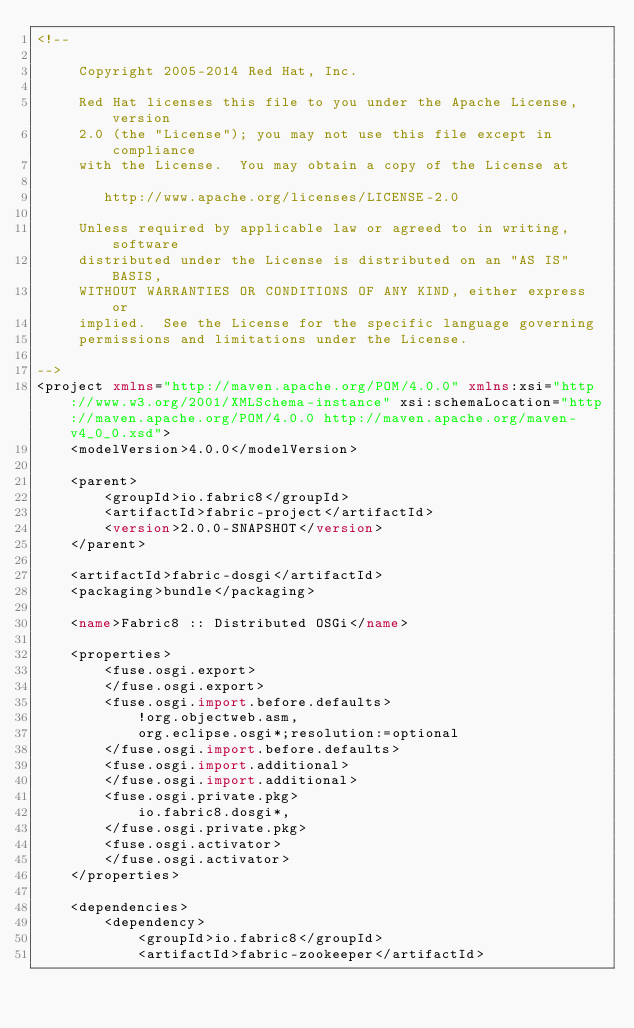<code> <loc_0><loc_0><loc_500><loc_500><_XML_><!--

     Copyright 2005-2014 Red Hat, Inc.

     Red Hat licenses this file to you under the Apache License, version
     2.0 (the "License"); you may not use this file except in compliance
     with the License.  You may obtain a copy of the License at

        http://www.apache.org/licenses/LICENSE-2.0

     Unless required by applicable law or agreed to in writing, software
     distributed under the License is distributed on an "AS IS" BASIS,
     WITHOUT WARRANTIES OR CONDITIONS OF ANY KIND, either express or
     implied.  See the License for the specific language governing
     permissions and limitations under the License.

-->
<project xmlns="http://maven.apache.org/POM/4.0.0" xmlns:xsi="http://www.w3.org/2001/XMLSchema-instance" xsi:schemaLocation="http://maven.apache.org/POM/4.0.0 http://maven.apache.org/maven-v4_0_0.xsd">
    <modelVersion>4.0.0</modelVersion>

    <parent>
        <groupId>io.fabric8</groupId>
        <artifactId>fabric-project</artifactId>
        <version>2.0.0-SNAPSHOT</version>
    </parent>

    <artifactId>fabric-dosgi</artifactId>
    <packaging>bundle</packaging>

    <name>Fabric8 :: Distributed OSGi</name>

    <properties>
        <fuse.osgi.export>
        </fuse.osgi.export>
        <fuse.osgi.import.before.defaults>
            !org.objectweb.asm,
            org.eclipse.osgi*;resolution:=optional
        </fuse.osgi.import.before.defaults>
        <fuse.osgi.import.additional>
        </fuse.osgi.import.additional>
        <fuse.osgi.private.pkg>
            io.fabric8.dosgi*,
        </fuse.osgi.private.pkg>
        <fuse.osgi.activator>
        </fuse.osgi.activator>
    </properties>

    <dependencies>
        <dependency>
            <groupId>io.fabric8</groupId>
            <artifactId>fabric-zookeeper</artifactId></code> 